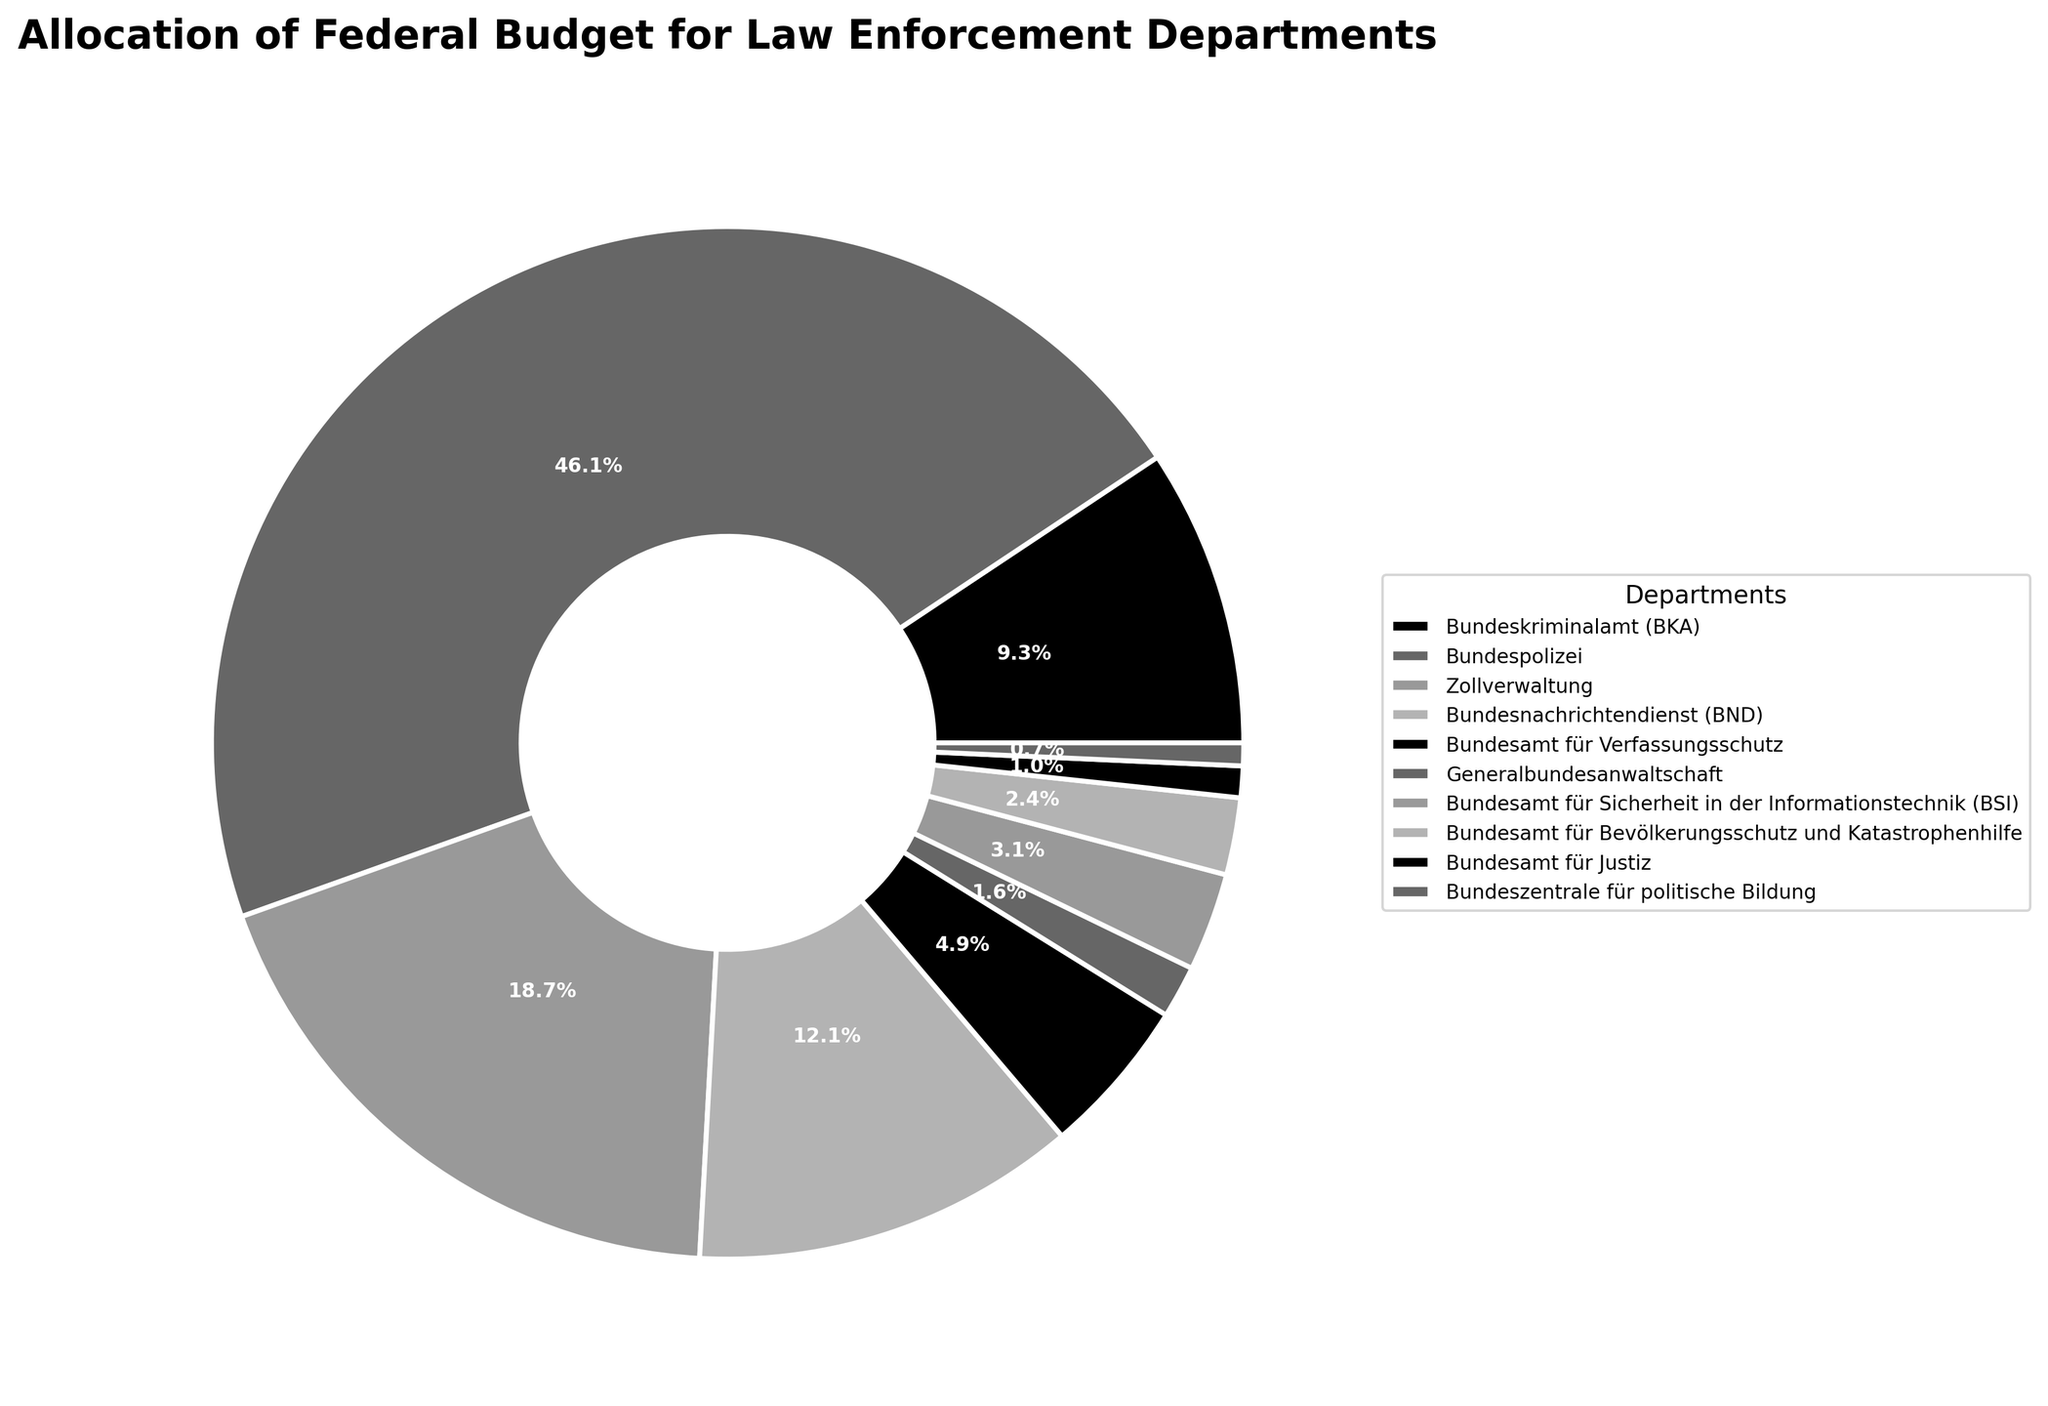Which department has the largest budget allocation? Look at the pie chart segments and identify the largest wedge. The Bundespolizei has the largest budget allocation.
Answer: Bundespolizei Which department receives more funding, the Bundeskriminalamt (BKA) or the Bundesnachrichtendienst (BND)? Compare the sizes of the wedges for BKA and BND. The BND wedge is larger than the BKA wedge.
Answer: Bundesnachrichtendienst (BND) What is the combined budget allocation for the Bundeskriminalamt (BKA) and the Zollverwaltung? Add the budget allocations of BKA (850 million Euros) and Zollverwaltung (1700 million Euros). 850 + 1700 = 2550
Answer: 2550 million Euros Which department receives the smallest share of the federal budget? Identify the smallest wedge on the pie chart. The Bundeszentrale für politische Bildung receives the smallest share.
Answer: Bundeszentrale für politische Bildung How does the budget allocation for the Bundespolizei compare to the total budget allocation for the Bundeskriminalamt (BKA), Bundesnachrichtendienst (BND), and Bundesamt für Verfassungsschutz combined? Add the budget allocations of BKA (850 million), BND (1100 million), and Bundesamt für Verfassungsschutz (450 million) to get 2400 million. The Bundespolizei's budget is 4200 million, which is larger.
Answer: Bundespolizei > BKA + BND + Bundesamt für Verfassungsschutz What percentage of the total budget is allocated to the Generalbundesanwaltschaft? Find the wedge labeled Generalbundesanwaltschaft. According to the pie chart, it represents 1.4% of the total budget.
Answer: 1.4% What is the difference in budget allocation between the Bundesnachrichtendienst (BND) and the Bundespolizei? Subtract the budget of BND (1100 million Euros) from the Bundespolizei's budget (4200 million Euros). 4200 - 1100 = 3100
Answer: 3100 million Euros Which department has a budget closest to 300 million Euros? Find the wedges near 300 million Euros. The Bundesamt für Sicherheit in der Informationstechnik (BSI) has a budget of 280 million Euros, which is closest to 300 million.
Answer: Bundesamt für Sicherheit in der Informationstechnik (BSI) What is the combined budget allocation for the Bundesamt für Bevölkerungsschutz und Katastrophenhilfe and the Bundesamt für Justiz? Add the budgets of Bundesamt für Bevölkerungsschutz und Katastrophenhilfe (220 million Euros) and Bundesamt für Justiz (90 million Euros). 220 + 90 = 310
Answer: 310 million Euros What fraction of the total budget is allocated to the Zollverwaltung? The pie chart indicates that the Zollverwaltung's allocation represents 13.5% of the total budget.
Answer: 13.5% 